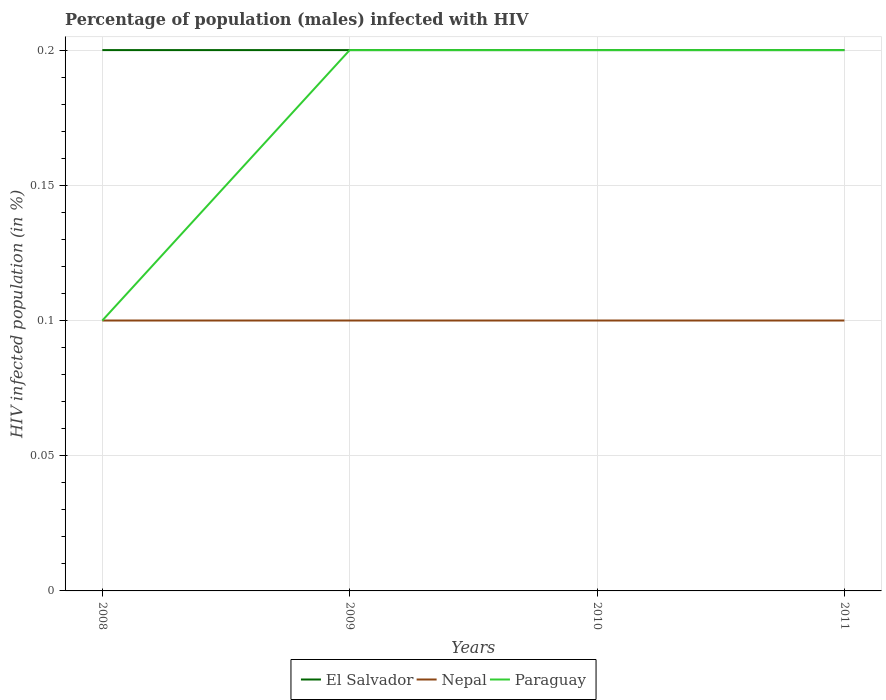How many different coloured lines are there?
Your answer should be compact. 3. In which year was the percentage of HIV infected male population in Paraguay maximum?
Provide a short and direct response. 2008. What is the total percentage of HIV infected male population in El Salvador in the graph?
Your response must be concise. 0. What is the difference between the highest and the second highest percentage of HIV infected male population in El Salvador?
Your answer should be very brief. 0. How many years are there in the graph?
Your answer should be very brief. 4. Does the graph contain grids?
Offer a very short reply. Yes. Where does the legend appear in the graph?
Offer a terse response. Bottom center. How many legend labels are there?
Your answer should be very brief. 3. What is the title of the graph?
Give a very brief answer. Percentage of population (males) infected with HIV. What is the label or title of the Y-axis?
Give a very brief answer. HIV infected population (in %). What is the HIV infected population (in %) in Nepal in 2008?
Offer a terse response. 0.1. What is the HIV infected population (in %) in Paraguay in 2009?
Your response must be concise. 0.2. What is the HIV infected population (in %) of El Salvador in 2010?
Provide a succinct answer. 0.2. What is the HIV infected population (in %) in Paraguay in 2010?
Your answer should be very brief. 0.2. What is the HIV infected population (in %) of Nepal in 2011?
Provide a short and direct response. 0.1. What is the HIV infected population (in %) in Paraguay in 2011?
Offer a very short reply. 0.2. Across all years, what is the maximum HIV infected population (in %) of El Salvador?
Provide a short and direct response. 0.2. Across all years, what is the maximum HIV infected population (in %) in Nepal?
Your answer should be very brief. 0.1. Across all years, what is the minimum HIV infected population (in %) in Nepal?
Provide a short and direct response. 0.1. Across all years, what is the minimum HIV infected population (in %) in Paraguay?
Keep it short and to the point. 0.1. What is the total HIV infected population (in %) of El Salvador in the graph?
Provide a short and direct response. 0.8. What is the difference between the HIV infected population (in %) in Nepal in 2008 and that in 2009?
Ensure brevity in your answer.  0. What is the difference between the HIV infected population (in %) in El Salvador in 2008 and that in 2010?
Provide a short and direct response. 0. What is the difference between the HIV infected population (in %) of Nepal in 2008 and that in 2010?
Give a very brief answer. 0. What is the difference between the HIV infected population (in %) in Nepal in 2009 and that in 2010?
Offer a terse response. 0. What is the difference between the HIV infected population (in %) in Paraguay in 2009 and that in 2010?
Your response must be concise. 0. What is the difference between the HIV infected population (in %) of Nepal in 2009 and that in 2011?
Offer a very short reply. 0. What is the difference between the HIV infected population (in %) in El Salvador in 2010 and that in 2011?
Provide a succinct answer. 0. What is the difference between the HIV infected population (in %) in Paraguay in 2010 and that in 2011?
Give a very brief answer. 0. What is the difference between the HIV infected population (in %) in El Salvador in 2008 and the HIV infected population (in %) in Paraguay in 2009?
Offer a terse response. 0. What is the difference between the HIV infected population (in %) in Nepal in 2008 and the HIV infected population (in %) in Paraguay in 2009?
Give a very brief answer. -0.1. What is the difference between the HIV infected population (in %) in El Salvador in 2008 and the HIV infected population (in %) in Nepal in 2010?
Provide a succinct answer. 0.1. What is the difference between the HIV infected population (in %) in El Salvador in 2008 and the HIV infected population (in %) in Paraguay in 2010?
Your answer should be compact. 0. What is the difference between the HIV infected population (in %) of El Salvador in 2008 and the HIV infected population (in %) of Nepal in 2011?
Make the answer very short. 0.1. What is the difference between the HIV infected population (in %) in Nepal in 2008 and the HIV infected population (in %) in Paraguay in 2011?
Your answer should be compact. -0.1. What is the difference between the HIV infected population (in %) in El Salvador in 2009 and the HIV infected population (in %) in Nepal in 2010?
Give a very brief answer. 0.1. What is the difference between the HIV infected population (in %) of El Salvador in 2009 and the HIV infected population (in %) of Paraguay in 2010?
Offer a very short reply. 0. What is the difference between the HIV infected population (in %) of El Salvador in 2009 and the HIV infected population (in %) of Paraguay in 2011?
Provide a succinct answer. 0. What is the difference between the HIV infected population (in %) in Nepal in 2009 and the HIV infected population (in %) in Paraguay in 2011?
Offer a very short reply. -0.1. What is the difference between the HIV infected population (in %) of El Salvador in 2010 and the HIV infected population (in %) of Nepal in 2011?
Your response must be concise. 0.1. What is the average HIV infected population (in %) in Nepal per year?
Your answer should be very brief. 0.1. What is the average HIV infected population (in %) of Paraguay per year?
Give a very brief answer. 0.17. In the year 2009, what is the difference between the HIV infected population (in %) in El Salvador and HIV infected population (in %) in Paraguay?
Make the answer very short. 0. In the year 2009, what is the difference between the HIV infected population (in %) of Nepal and HIV infected population (in %) of Paraguay?
Offer a very short reply. -0.1. In the year 2010, what is the difference between the HIV infected population (in %) in El Salvador and HIV infected population (in %) in Nepal?
Your response must be concise. 0.1. In the year 2010, what is the difference between the HIV infected population (in %) of Nepal and HIV infected population (in %) of Paraguay?
Provide a short and direct response. -0.1. In the year 2011, what is the difference between the HIV infected population (in %) in El Salvador and HIV infected population (in %) in Nepal?
Make the answer very short. 0.1. In the year 2011, what is the difference between the HIV infected population (in %) of El Salvador and HIV infected population (in %) of Paraguay?
Ensure brevity in your answer.  0. In the year 2011, what is the difference between the HIV infected population (in %) in Nepal and HIV infected population (in %) in Paraguay?
Make the answer very short. -0.1. What is the ratio of the HIV infected population (in %) in El Salvador in 2008 to that in 2009?
Ensure brevity in your answer.  1. What is the ratio of the HIV infected population (in %) in Nepal in 2008 to that in 2010?
Offer a very short reply. 1. What is the ratio of the HIV infected population (in %) of Nepal in 2008 to that in 2011?
Offer a terse response. 1. What is the ratio of the HIV infected population (in %) of El Salvador in 2009 to that in 2010?
Keep it short and to the point. 1. What is the ratio of the HIV infected population (in %) of El Salvador in 2009 to that in 2011?
Provide a succinct answer. 1. What is the ratio of the HIV infected population (in %) of El Salvador in 2010 to that in 2011?
Your response must be concise. 1. What is the ratio of the HIV infected population (in %) in Paraguay in 2010 to that in 2011?
Your answer should be compact. 1. What is the difference between the highest and the second highest HIV infected population (in %) of Paraguay?
Ensure brevity in your answer.  0. What is the difference between the highest and the lowest HIV infected population (in %) of El Salvador?
Provide a succinct answer. 0. What is the difference between the highest and the lowest HIV infected population (in %) in Paraguay?
Offer a terse response. 0.1. 